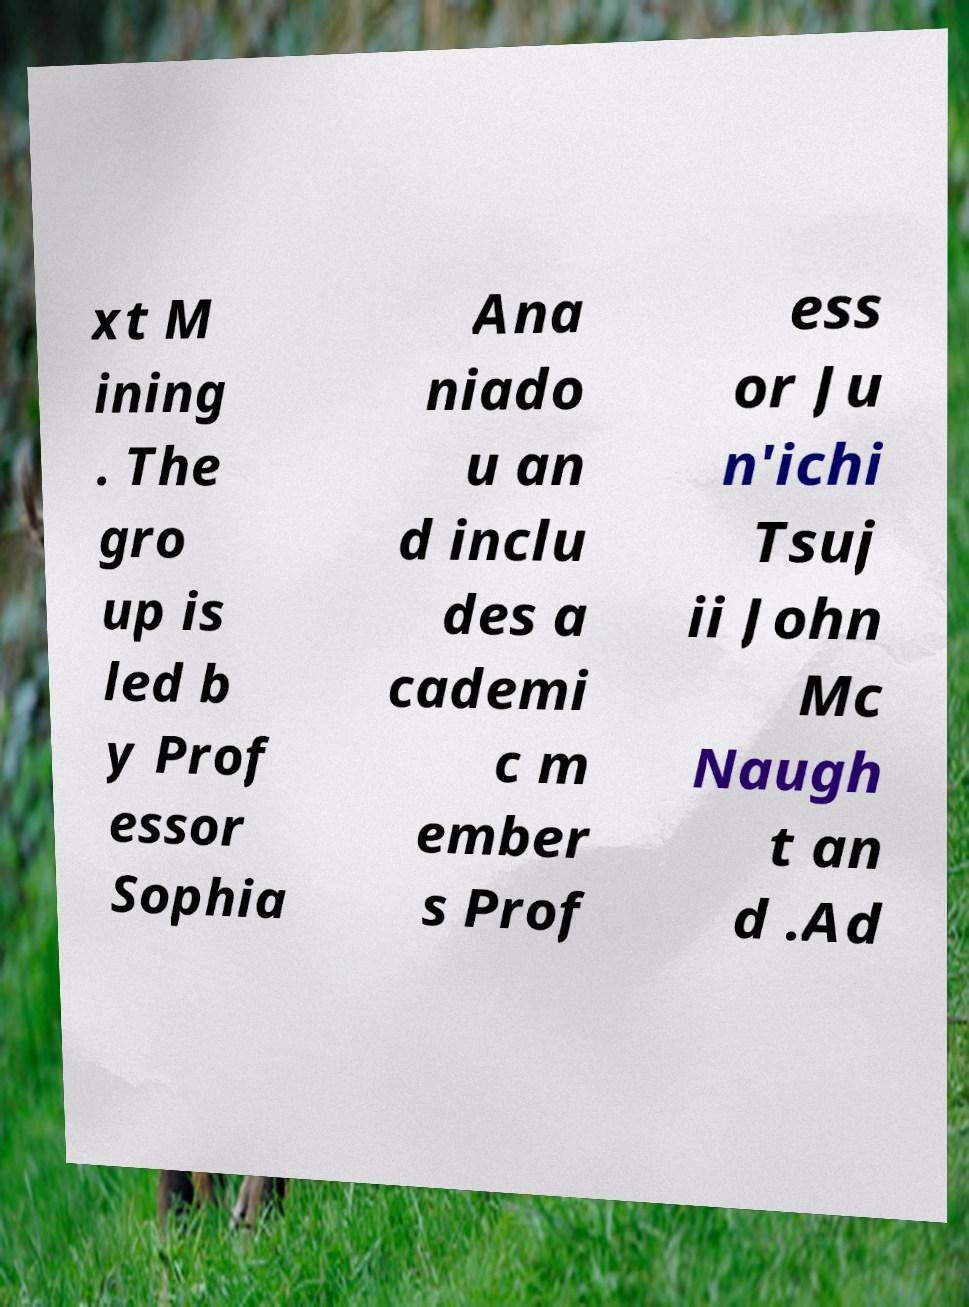Could you extract and type out the text from this image? xt M ining . The gro up is led b y Prof essor Sophia Ana niado u an d inclu des a cademi c m ember s Prof ess or Ju n'ichi Tsuj ii John Mc Naugh t an d .Ad 